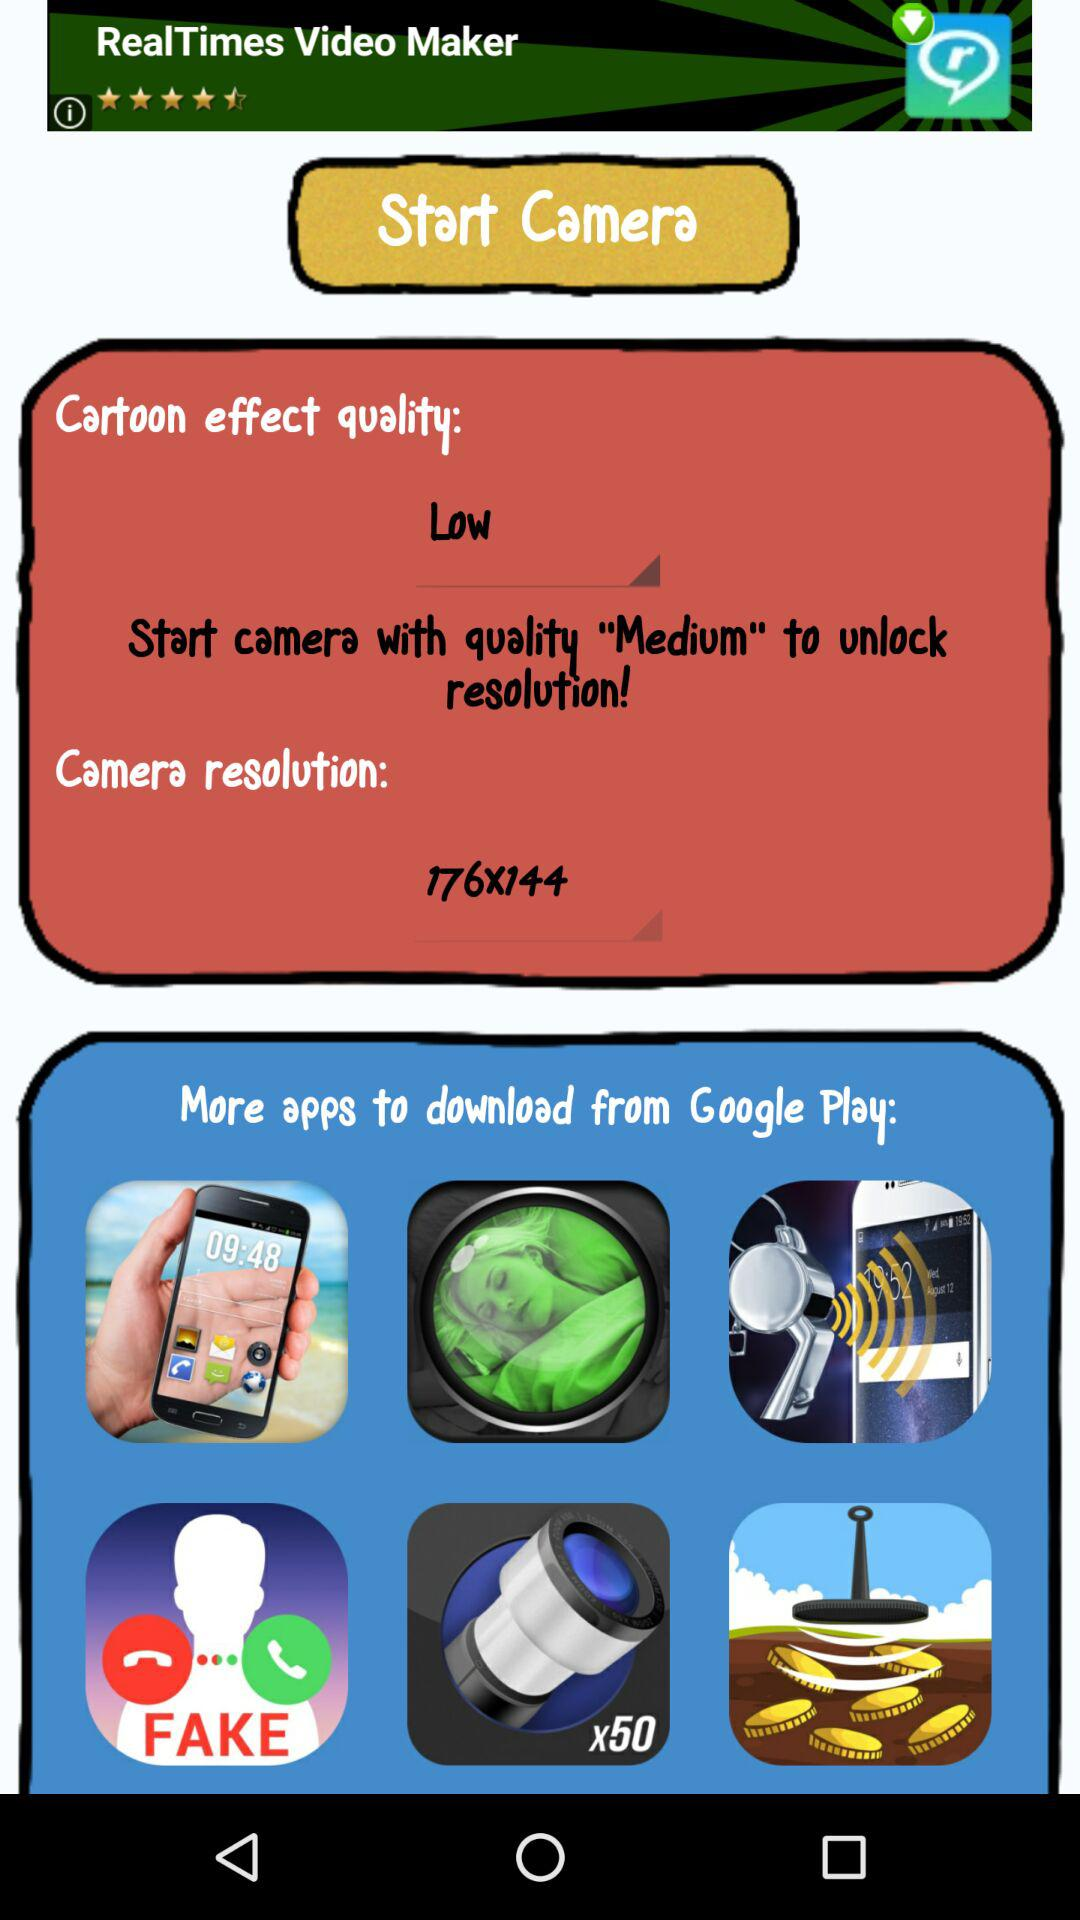What is the camera resolution? The camera resolution is 176x144. 